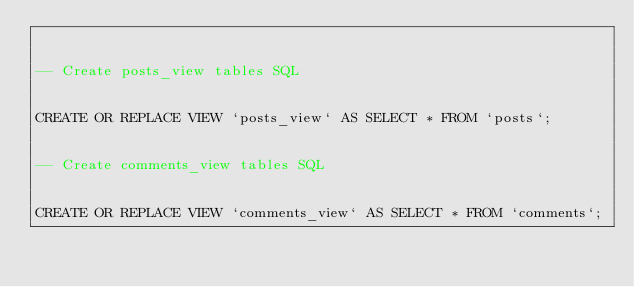Convert code to text. <code><loc_0><loc_0><loc_500><loc_500><_SQL_>

-- Create posts_view tables SQL


CREATE OR REPLACE VIEW `posts_view` AS SELECT * FROM `posts`;


-- Create comments_view tables SQL


CREATE OR REPLACE VIEW `comments_view` AS SELECT * FROM `comments`;

</code> 